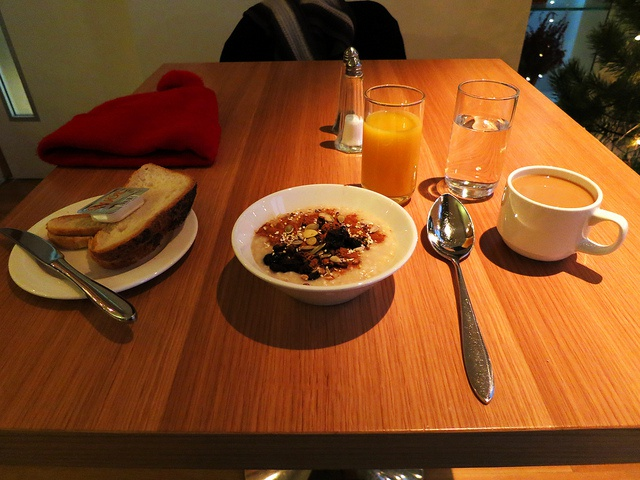Describe the objects in this image and their specific colors. I can see dining table in maroon, darkgreen, black, red, and orange tones, bowl in darkgreen, tan, black, and maroon tones, cup in darkgreen, red, orange, and salmon tones, potted plant in darkgreen, black, and olive tones, and sandwich in darkgreen, olive, black, and maroon tones in this image. 